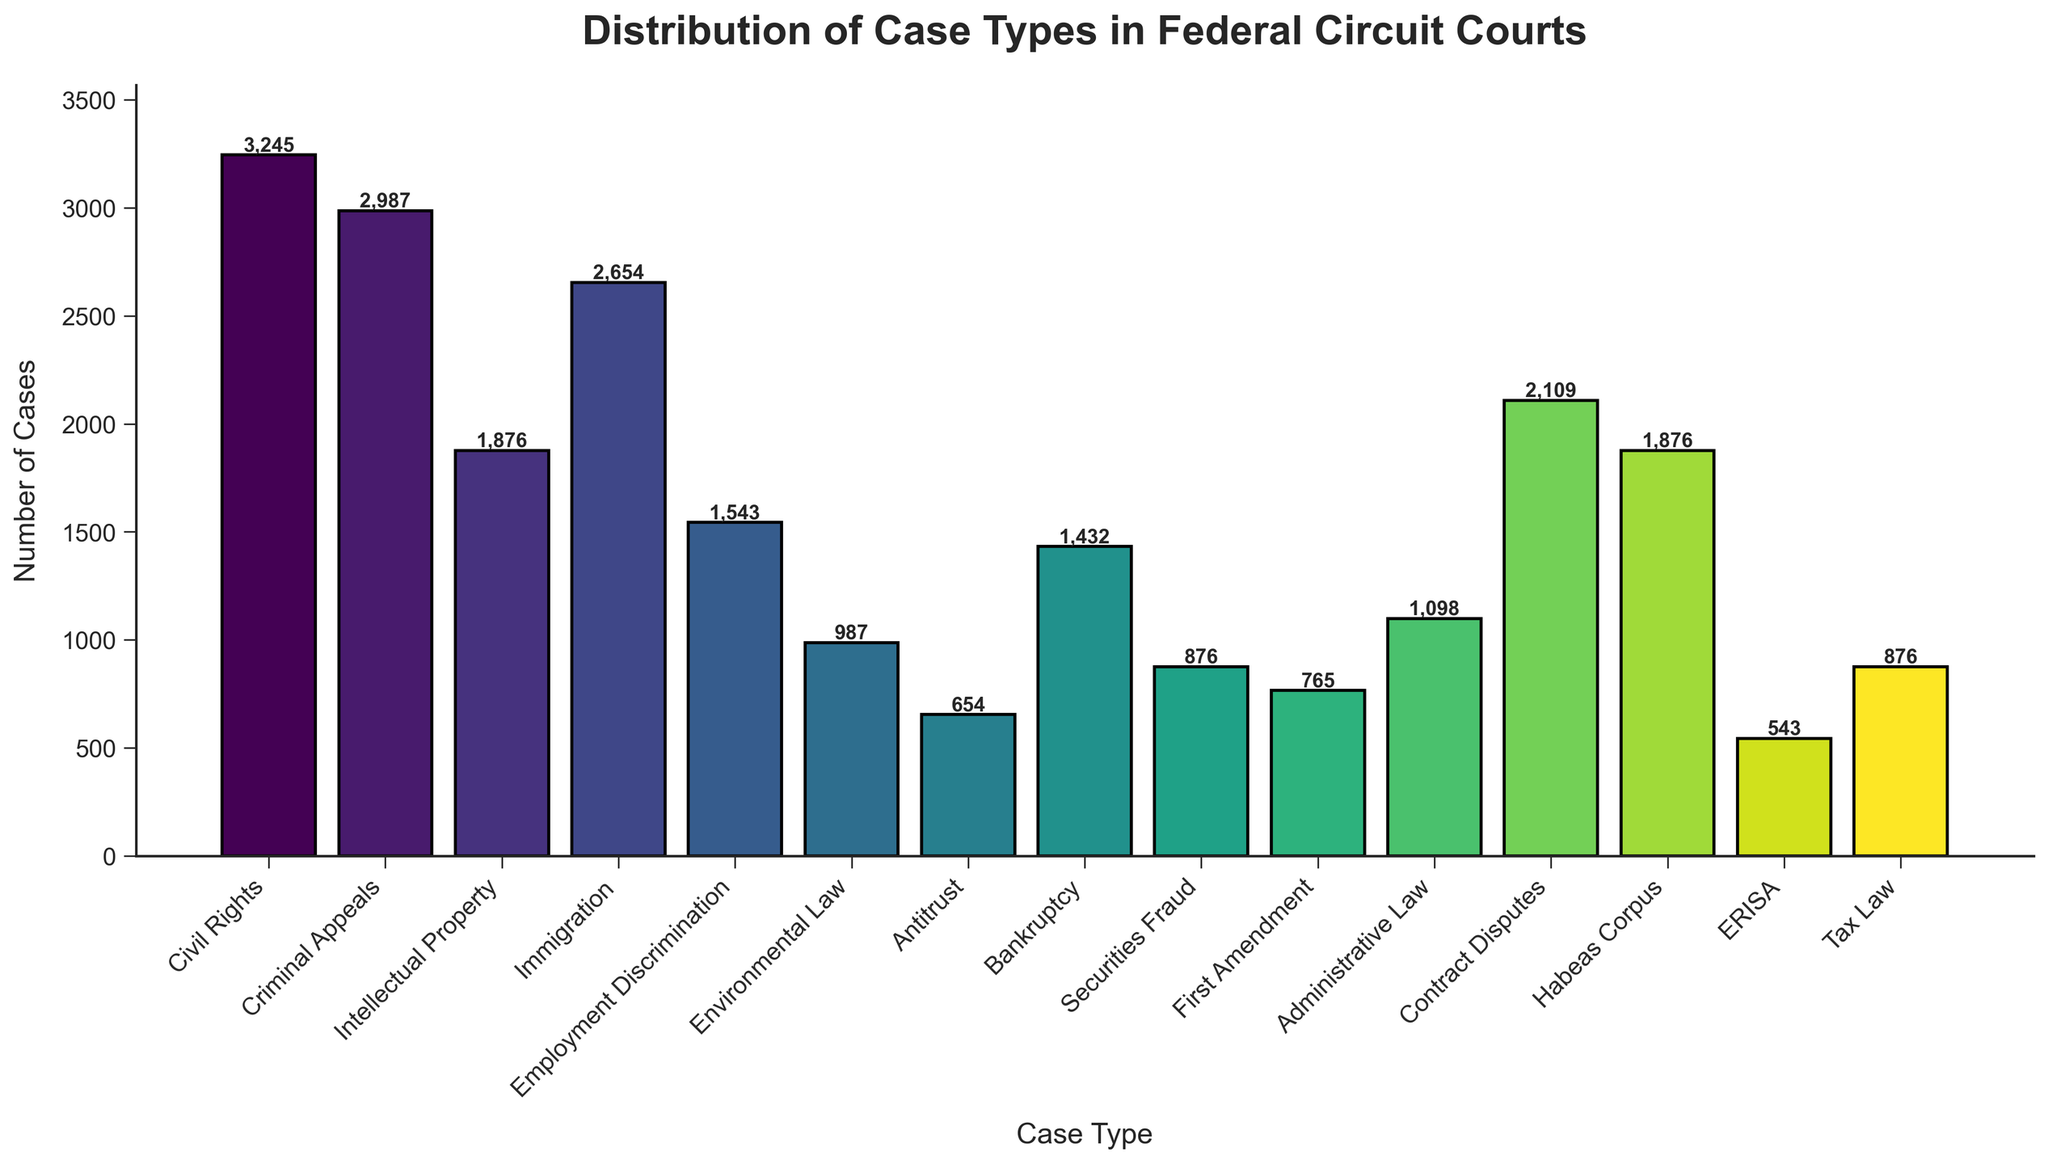What's the most common type of case in federal circuit courts? The tallest bar represents the most common case type. By comparing the height of all bars, "Civil Rights" is the tallest.
Answer: Civil Rights Which two case types have an identical number of cases? Looking closely at the bar heights and the text labels, "Intellectual Property" and "Habeas Corpus" both have 1,876 cases.
Answer: Intellectual Property and Habeas Corpus What is the combined number of cases for Criminal Appeals, Immigration, and Employment Discrimination? Add the numbers for Criminal Appeals (2,987), Immigration (2,654), and Employment Discrimination (1,543). The sum is 2,987 + 2,654 + 1,543 = 7,184 cases.
Answer: 7,184 Which case type has a higher number of cases: Administrative Law or Bankruptcy? Compare the heights of the bars for Administrative Law (1,098) and Bankruptcy (1,432). Bankruptcy is taller.
Answer: Bankruptcy How many fewer cases does Antitrust have compared to Intellectual Property? Subtract the number of cases in Antitrust (654) from Intellectual Property (1,876). The difference is 1,876 - 654 = 1,222 cases.
Answer: 1,222 How many case types have fewer than 1,000 cases? Identify the bars with a height less than 1,000: Environmental Law (987), Antitrust (654), First Amendment (765), ERISA (543), and Tax Law (876). There are 5 such case types.
Answer: 5 Which case type has the shortest bar? The shortest bar represents the case type with the fewest cases. ERISA has 543 cases, which is the shortest.
Answer: ERISA What is the average number of cases for the five least common case types? List the five least common case types by their numbers: ERISA (543), Antitrust (654), First Amendment (765), Tax Law (876), and Environmental Law (987). Their total is 543 + 654 + 765 + 876 + 987 = 3,825. The average is 3,825 / 5 = 765 cases.
Answer: 765 By how much does the number of Civil Rights cases exceed the number of Securities Fraud cases? Subtract the number of Securities Fraud cases (876) from Civil Rights cases (3,245). The difference is 3,245 - 876 = 2,369 cases.
Answer: 2,369 